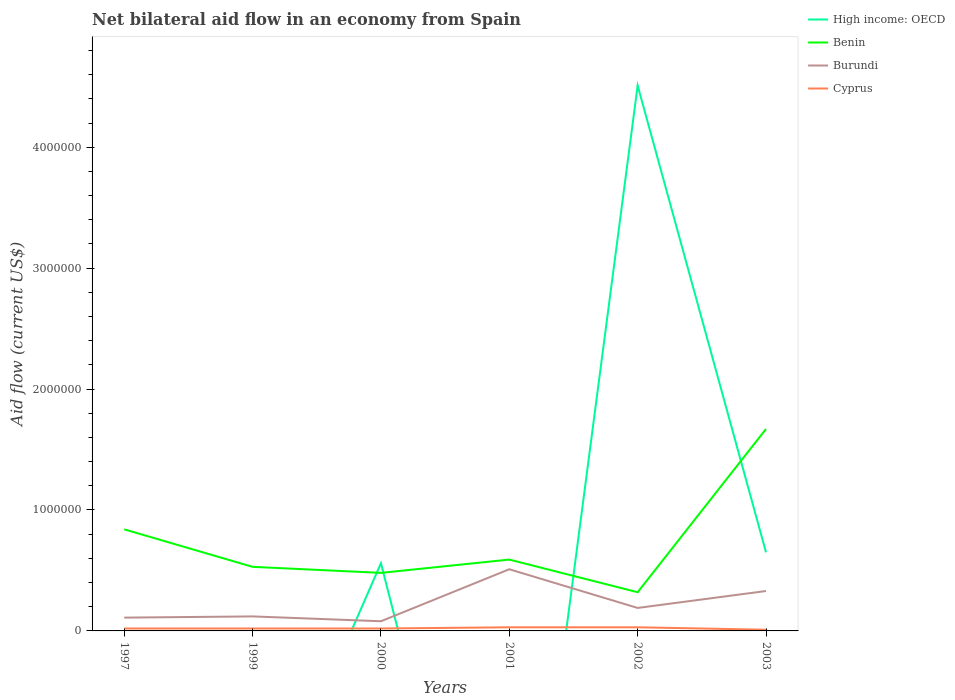Does the line corresponding to Benin intersect with the line corresponding to High income: OECD?
Give a very brief answer. Yes. Across all years, what is the maximum net bilateral aid flow in Benin?
Provide a short and direct response. 3.20e+05. What is the total net bilateral aid flow in Burundi in the graph?
Keep it short and to the point. -3.90e+05. What is the difference between the highest and the second highest net bilateral aid flow in Benin?
Make the answer very short. 1.35e+06. Is the net bilateral aid flow in Cyprus strictly greater than the net bilateral aid flow in Benin over the years?
Ensure brevity in your answer.  Yes. How many years are there in the graph?
Provide a succinct answer. 6. Does the graph contain grids?
Keep it short and to the point. No. Where does the legend appear in the graph?
Your answer should be compact. Top right. How many legend labels are there?
Keep it short and to the point. 4. How are the legend labels stacked?
Offer a terse response. Vertical. What is the title of the graph?
Your answer should be compact. Net bilateral aid flow in an economy from Spain. Does "Heavily indebted poor countries" appear as one of the legend labels in the graph?
Make the answer very short. No. What is the label or title of the X-axis?
Your response must be concise. Years. What is the Aid flow (current US$) of High income: OECD in 1997?
Make the answer very short. 0. What is the Aid flow (current US$) of Benin in 1997?
Offer a terse response. 8.40e+05. What is the Aid flow (current US$) of Burundi in 1997?
Your response must be concise. 1.10e+05. What is the Aid flow (current US$) of High income: OECD in 1999?
Provide a succinct answer. 0. What is the Aid flow (current US$) in Benin in 1999?
Provide a succinct answer. 5.30e+05. What is the Aid flow (current US$) in Burundi in 1999?
Keep it short and to the point. 1.20e+05. What is the Aid flow (current US$) of Cyprus in 1999?
Your answer should be compact. 2.00e+04. What is the Aid flow (current US$) in High income: OECD in 2000?
Offer a terse response. 5.60e+05. What is the Aid flow (current US$) of Benin in 2000?
Give a very brief answer. 4.80e+05. What is the Aid flow (current US$) in Burundi in 2000?
Your answer should be very brief. 8.00e+04. What is the Aid flow (current US$) of High income: OECD in 2001?
Offer a very short reply. 0. What is the Aid flow (current US$) in Benin in 2001?
Make the answer very short. 5.90e+05. What is the Aid flow (current US$) in Burundi in 2001?
Give a very brief answer. 5.10e+05. What is the Aid flow (current US$) of High income: OECD in 2002?
Keep it short and to the point. 4.51e+06. What is the Aid flow (current US$) of Benin in 2002?
Make the answer very short. 3.20e+05. What is the Aid flow (current US$) of Burundi in 2002?
Make the answer very short. 1.90e+05. What is the Aid flow (current US$) of High income: OECD in 2003?
Give a very brief answer. 6.50e+05. What is the Aid flow (current US$) in Benin in 2003?
Offer a terse response. 1.67e+06. What is the Aid flow (current US$) of Burundi in 2003?
Provide a succinct answer. 3.30e+05. Across all years, what is the maximum Aid flow (current US$) of High income: OECD?
Ensure brevity in your answer.  4.51e+06. Across all years, what is the maximum Aid flow (current US$) of Benin?
Offer a terse response. 1.67e+06. Across all years, what is the maximum Aid flow (current US$) in Burundi?
Provide a short and direct response. 5.10e+05. Across all years, what is the maximum Aid flow (current US$) in Cyprus?
Provide a short and direct response. 3.00e+04. Across all years, what is the minimum Aid flow (current US$) of High income: OECD?
Your answer should be compact. 0. Across all years, what is the minimum Aid flow (current US$) in Benin?
Provide a succinct answer. 3.20e+05. Across all years, what is the minimum Aid flow (current US$) of Burundi?
Provide a short and direct response. 8.00e+04. Across all years, what is the minimum Aid flow (current US$) in Cyprus?
Your answer should be compact. 10000. What is the total Aid flow (current US$) in High income: OECD in the graph?
Ensure brevity in your answer.  5.72e+06. What is the total Aid flow (current US$) of Benin in the graph?
Your answer should be very brief. 4.43e+06. What is the total Aid flow (current US$) of Burundi in the graph?
Your answer should be compact. 1.34e+06. What is the difference between the Aid flow (current US$) in Cyprus in 1997 and that in 1999?
Keep it short and to the point. 0. What is the difference between the Aid flow (current US$) of Benin in 1997 and that in 2000?
Provide a short and direct response. 3.60e+05. What is the difference between the Aid flow (current US$) of Burundi in 1997 and that in 2000?
Make the answer very short. 3.00e+04. What is the difference between the Aid flow (current US$) of Cyprus in 1997 and that in 2000?
Make the answer very short. 0. What is the difference between the Aid flow (current US$) in Benin in 1997 and that in 2001?
Give a very brief answer. 2.50e+05. What is the difference between the Aid flow (current US$) in Burundi in 1997 and that in 2001?
Ensure brevity in your answer.  -4.00e+05. What is the difference between the Aid flow (current US$) in Benin in 1997 and that in 2002?
Make the answer very short. 5.20e+05. What is the difference between the Aid flow (current US$) in Burundi in 1997 and that in 2002?
Provide a short and direct response. -8.00e+04. What is the difference between the Aid flow (current US$) in Benin in 1997 and that in 2003?
Keep it short and to the point. -8.30e+05. What is the difference between the Aid flow (current US$) of Cyprus in 1997 and that in 2003?
Your response must be concise. 10000. What is the difference between the Aid flow (current US$) in Burundi in 1999 and that in 2000?
Give a very brief answer. 4.00e+04. What is the difference between the Aid flow (current US$) of Benin in 1999 and that in 2001?
Your answer should be very brief. -6.00e+04. What is the difference between the Aid flow (current US$) of Burundi in 1999 and that in 2001?
Your answer should be compact. -3.90e+05. What is the difference between the Aid flow (current US$) of Cyprus in 1999 and that in 2001?
Provide a succinct answer. -10000. What is the difference between the Aid flow (current US$) of Benin in 1999 and that in 2003?
Make the answer very short. -1.14e+06. What is the difference between the Aid flow (current US$) of Benin in 2000 and that in 2001?
Give a very brief answer. -1.10e+05. What is the difference between the Aid flow (current US$) of Burundi in 2000 and that in 2001?
Make the answer very short. -4.30e+05. What is the difference between the Aid flow (current US$) of Cyprus in 2000 and that in 2001?
Ensure brevity in your answer.  -10000. What is the difference between the Aid flow (current US$) of High income: OECD in 2000 and that in 2002?
Your answer should be compact. -3.95e+06. What is the difference between the Aid flow (current US$) of Burundi in 2000 and that in 2002?
Offer a very short reply. -1.10e+05. What is the difference between the Aid flow (current US$) in Benin in 2000 and that in 2003?
Offer a terse response. -1.19e+06. What is the difference between the Aid flow (current US$) of Burundi in 2000 and that in 2003?
Keep it short and to the point. -2.50e+05. What is the difference between the Aid flow (current US$) in Benin in 2001 and that in 2002?
Your answer should be very brief. 2.70e+05. What is the difference between the Aid flow (current US$) in Cyprus in 2001 and that in 2002?
Offer a very short reply. 0. What is the difference between the Aid flow (current US$) of Benin in 2001 and that in 2003?
Your answer should be compact. -1.08e+06. What is the difference between the Aid flow (current US$) in Burundi in 2001 and that in 2003?
Your response must be concise. 1.80e+05. What is the difference between the Aid flow (current US$) of Cyprus in 2001 and that in 2003?
Provide a short and direct response. 2.00e+04. What is the difference between the Aid flow (current US$) of High income: OECD in 2002 and that in 2003?
Offer a terse response. 3.86e+06. What is the difference between the Aid flow (current US$) in Benin in 2002 and that in 2003?
Make the answer very short. -1.35e+06. What is the difference between the Aid flow (current US$) in Burundi in 2002 and that in 2003?
Your answer should be very brief. -1.40e+05. What is the difference between the Aid flow (current US$) in Cyprus in 2002 and that in 2003?
Your answer should be very brief. 2.00e+04. What is the difference between the Aid flow (current US$) of Benin in 1997 and the Aid flow (current US$) of Burundi in 1999?
Give a very brief answer. 7.20e+05. What is the difference between the Aid flow (current US$) of Benin in 1997 and the Aid flow (current US$) of Cyprus in 1999?
Your answer should be compact. 8.20e+05. What is the difference between the Aid flow (current US$) in Burundi in 1997 and the Aid flow (current US$) in Cyprus in 1999?
Make the answer very short. 9.00e+04. What is the difference between the Aid flow (current US$) of Benin in 1997 and the Aid flow (current US$) of Burundi in 2000?
Ensure brevity in your answer.  7.60e+05. What is the difference between the Aid flow (current US$) in Benin in 1997 and the Aid flow (current US$) in Cyprus in 2000?
Your answer should be very brief. 8.20e+05. What is the difference between the Aid flow (current US$) in Benin in 1997 and the Aid flow (current US$) in Burundi in 2001?
Make the answer very short. 3.30e+05. What is the difference between the Aid flow (current US$) in Benin in 1997 and the Aid flow (current US$) in Cyprus in 2001?
Give a very brief answer. 8.10e+05. What is the difference between the Aid flow (current US$) in Benin in 1997 and the Aid flow (current US$) in Burundi in 2002?
Offer a very short reply. 6.50e+05. What is the difference between the Aid flow (current US$) in Benin in 1997 and the Aid flow (current US$) in Cyprus in 2002?
Keep it short and to the point. 8.10e+05. What is the difference between the Aid flow (current US$) in Benin in 1997 and the Aid flow (current US$) in Burundi in 2003?
Your response must be concise. 5.10e+05. What is the difference between the Aid flow (current US$) of Benin in 1997 and the Aid flow (current US$) of Cyprus in 2003?
Your answer should be very brief. 8.30e+05. What is the difference between the Aid flow (current US$) of Burundi in 1997 and the Aid flow (current US$) of Cyprus in 2003?
Offer a very short reply. 1.00e+05. What is the difference between the Aid flow (current US$) in Benin in 1999 and the Aid flow (current US$) in Cyprus in 2000?
Your response must be concise. 5.10e+05. What is the difference between the Aid flow (current US$) in Burundi in 1999 and the Aid flow (current US$) in Cyprus in 2000?
Your response must be concise. 1.00e+05. What is the difference between the Aid flow (current US$) in Benin in 1999 and the Aid flow (current US$) in Cyprus in 2002?
Offer a terse response. 5.00e+05. What is the difference between the Aid flow (current US$) of Benin in 1999 and the Aid flow (current US$) of Burundi in 2003?
Ensure brevity in your answer.  2.00e+05. What is the difference between the Aid flow (current US$) in Benin in 1999 and the Aid flow (current US$) in Cyprus in 2003?
Offer a terse response. 5.20e+05. What is the difference between the Aid flow (current US$) in Burundi in 1999 and the Aid flow (current US$) in Cyprus in 2003?
Your answer should be compact. 1.10e+05. What is the difference between the Aid flow (current US$) in High income: OECD in 2000 and the Aid flow (current US$) in Benin in 2001?
Your answer should be compact. -3.00e+04. What is the difference between the Aid flow (current US$) in High income: OECD in 2000 and the Aid flow (current US$) in Cyprus in 2001?
Offer a very short reply. 5.30e+05. What is the difference between the Aid flow (current US$) of Benin in 2000 and the Aid flow (current US$) of Burundi in 2001?
Provide a succinct answer. -3.00e+04. What is the difference between the Aid flow (current US$) of Benin in 2000 and the Aid flow (current US$) of Cyprus in 2001?
Offer a terse response. 4.50e+05. What is the difference between the Aid flow (current US$) in High income: OECD in 2000 and the Aid flow (current US$) in Cyprus in 2002?
Your response must be concise. 5.30e+05. What is the difference between the Aid flow (current US$) of High income: OECD in 2000 and the Aid flow (current US$) of Benin in 2003?
Make the answer very short. -1.11e+06. What is the difference between the Aid flow (current US$) of Burundi in 2000 and the Aid flow (current US$) of Cyprus in 2003?
Provide a succinct answer. 7.00e+04. What is the difference between the Aid flow (current US$) in Benin in 2001 and the Aid flow (current US$) in Cyprus in 2002?
Your answer should be very brief. 5.60e+05. What is the difference between the Aid flow (current US$) in Benin in 2001 and the Aid flow (current US$) in Cyprus in 2003?
Your response must be concise. 5.80e+05. What is the difference between the Aid flow (current US$) in High income: OECD in 2002 and the Aid flow (current US$) in Benin in 2003?
Make the answer very short. 2.84e+06. What is the difference between the Aid flow (current US$) in High income: OECD in 2002 and the Aid flow (current US$) in Burundi in 2003?
Provide a short and direct response. 4.18e+06. What is the difference between the Aid flow (current US$) of High income: OECD in 2002 and the Aid flow (current US$) of Cyprus in 2003?
Keep it short and to the point. 4.50e+06. What is the difference between the Aid flow (current US$) in Burundi in 2002 and the Aid flow (current US$) in Cyprus in 2003?
Offer a terse response. 1.80e+05. What is the average Aid flow (current US$) in High income: OECD per year?
Your response must be concise. 9.53e+05. What is the average Aid flow (current US$) of Benin per year?
Your answer should be very brief. 7.38e+05. What is the average Aid flow (current US$) of Burundi per year?
Offer a terse response. 2.23e+05. What is the average Aid flow (current US$) in Cyprus per year?
Your response must be concise. 2.17e+04. In the year 1997, what is the difference between the Aid flow (current US$) of Benin and Aid flow (current US$) of Burundi?
Keep it short and to the point. 7.30e+05. In the year 1997, what is the difference between the Aid flow (current US$) of Benin and Aid flow (current US$) of Cyprus?
Keep it short and to the point. 8.20e+05. In the year 1997, what is the difference between the Aid flow (current US$) in Burundi and Aid flow (current US$) in Cyprus?
Offer a very short reply. 9.00e+04. In the year 1999, what is the difference between the Aid flow (current US$) of Benin and Aid flow (current US$) of Burundi?
Keep it short and to the point. 4.10e+05. In the year 1999, what is the difference between the Aid flow (current US$) in Benin and Aid flow (current US$) in Cyprus?
Offer a terse response. 5.10e+05. In the year 1999, what is the difference between the Aid flow (current US$) in Burundi and Aid flow (current US$) in Cyprus?
Offer a terse response. 1.00e+05. In the year 2000, what is the difference between the Aid flow (current US$) in High income: OECD and Aid flow (current US$) in Burundi?
Offer a terse response. 4.80e+05. In the year 2000, what is the difference between the Aid flow (current US$) in High income: OECD and Aid flow (current US$) in Cyprus?
Provide a short and direct response. 5.40e+05. In the year 2000, what is the difference between the Aid flow (current US$) of Burundi and Aid flow (current US$) of Cyprus?
Give a very brief answer. 6.00e+04. In the year 2001, what is the difference between the Aid flow (current US$) of Benin and Aid flow (current US$) of Burundi?
Provide a short and direct response. 8.00e+04. In the year 2001, what is the difference between the Aid flow (current US$) of Benin and Aid flow (current US$) of Cyprus?
Give a very brief answer. 5.60e+05. In the year 2002, what is the difference between the Aid flow (current US$) of High income: OECD and Aid flow (current US$) of Benin?
Offer a very short reply. 4.19e+06. In the year 2002, what is the difference between the Aid flow (current US$) in High income: OECD and Aid flow (current US$) in Burundi?
Your answer should be compact. 4.32e+06. In the year 2002, what is the difference between the Aid flow (current US$) in High income: OECD and Aid flow (current US$) in Cyprus?
Give a very brief answer. 4.48e+06. In the year 2002, what is the difference between the Aid flow (current US$) in Burundi and Aid flow (current US$) in Cyprus?
Give a very brief answer. 1.60e+05. In the year 2003, what is the difference between the Aid flow (current US$) in High income: OECD and Aid flow (current US$) in Benin?
Make the answer very short. -1.02e+06. In the year 2003, what is the difference between the Aid flow (current US$) of High income: OECD and Aid flow (current US$) of Burundi?
Your answer should be very brief. 3.20e+05. In the year 2003, what is the difference between the Aid flow (current US$) of High income: OECD and Aid flow (current US$) of Cyprus?
Ensure brevity in your answer.  6.40e+05. In the year 2003, what is the difference between the Aid flow (current US$) of Benin and Aid flow (current US$) of Burundi?
Your answer should be very brief. 1.34e+06. In the year 2003, what is the difference between the Aid flow (current US$) in Benin and Aid flow (current US$) in Cyprus?
Give a very brief answer. 1.66e+06. In the year 2003, what is the difference between the Aid flow (current US$) in Burundi and Aid flow (current US$) in Cyprus?
Your response must be concise. 3.20e+05. What is the ratio of the Aid flow (current US$) in Benin in 1997 to that in 1999?
Your answer should be very brief. 1.58. What is the ratio of the Aid flow (current US$) in Burundi in 1997 to that in 1999?
Your answer should be very brief. 0.92. What is the ratio of the Aid flow (current US$) in Benin in 1997 to that in 2000?
Offer a very short reply. 1.75. What is the ratio of the Aid flow (current US$) in Burundi in 1997 to that in 2000?
Offer a terse response. 1.38. What is the ratio of the Aid flow (current US$) of Benin in 1997 to that in 2001?
Give a very brief answer. 1.42. What is the ratio of the Aid flow (current US$) in Burundi in 1997 to that in 2001?
Give a very brief answer. 0.22. What is the ratio of the Aid flow (current US$) of Cyprus in 1997 to that in 2001?
Your answer should be very brief. 0.67. What is the ratio of the Aid flow (current US$) of Benin in 1997 to that in 2002?
Give a very brief answer. 2.62. What is the ratio of the Aid flow (current US$) of Burundi in 1997 to that in 2002?
Offer a terse response. 0.58. What is the ratio of the Aid flow (current US$) in Cyprus in 1997 to that in 2002?
Offer a very short reply. 0.67. What is the ratio of the Aid flow (current US$) of Benin in 1997 to that in 2003?
Make the answer very short. 0.5. What is the ratio of the Aid flow (current US$) of Burundi in 1997 to that in 2003?
Ensure brevity in your answer.  0.33. What is the ratio of the Aid flow (current US$) of Cyprus in 1997 to that in 2003?
Provide a short and direct response. 2. What is the ratio of the Aid flow (current US$) in Benin in 1999 to that in 2000?
Make the answer very short. 1.1. What is the ratio of the Aid flow (current US$) of Burundi in 1999 to that in 2000?
Offer a terse response. 1.5. What is the ratio of the Aid flow (current US$) of Cyprus in 1999 to that in 2000?
Your answer should be compact. 1. What is the ratio of the Aid flow (current US$) in Benin in 1999 to that in 2001?
Your answer should be compact. 0.9. What is the ratio of the Aid flow (current US$) in Burundi in 1999 to that in 2001?
Your answer should be very brief. 0.24. What is the ratio of the Aid flow (current US$) of Cyprus in 1999 to that in 2001?
Ensure brevity in your answer.  0.67. What is the ratio of the Aid flow (current US$) in Benin in 1999 to that in 2002?
Offer a terse response. 1.66. What is the ratio of the Aid flow (current US$) in Burundi in 1999 to that in 2002?
Give a very brief answer. 0.63. What is the ratio of the Aid flow (current US$) in Cyprus in 1999 to that in 2002?
Make the answer very short. 0.67. What is the ratio of the Aid flow (current US$) in Benin in 1999 to that in 2003?
Give a very brief answer. 0.32. What is the ratio of the Aid flow (current US$) in Burundi in 1999 to that in 2003?
Make the answer very short. 0.36. What is the ratio of the Aid flow (current US$) in Benin in 2000 to that in 2001?
Provide a short and direct response. 0.81. What is the ratio of the Aid flow (current US$) in Burundi in 2000 to that in 2001?
Provide a short and direct response. 0.16. What is the ratio of the Aid flow (current US$) in High income: OECD in 2000 to that in 2002?
Provide a succinct answer. 0.12. What is the ratio of the Aid flow (current US$) of Burundi in 2000 to that in 2002?
Give a very brief answer. 0.42. What is the ratio of the Aid flow (current US$) of Cyprus in 2000 to that in 2002?
Ensure brevity in your answer.  0.67. What is the ratio of the Aid flow (current US$) in High income: OECD in 2000 to that in 2003?
Make the answer very short. 0.86. What is the ratio of the Aid flow (current US$) in Benin in 2000 to that in 2003?
Your answer should be very brief. 0.29. What is the ratio of the Aid flow (current US$) of Burundi in 2000 to that in 2003?
Offer a very short reply. 0.24. What is the ratio of the Aid flow (current US$) of Cyprus in 2000 to that in 2003?
Keep it short and to the point. 2. What is the ratio of the Aid flow (current US$) in Benin in 2001 to that in 2002?
Your answer should be very brief. 1.84. What is the ratio of the Aid flow (current US$) in Burundi in 2001 to that in 2002?
Provide a short and direct response. 2.68. What is the ratio of the Aid flow (current US$) of Cyprus in 2001 to that in 2002?
Offer a terse response. 1. What is the ratio of the Aid flow (current US$) in Benin in 2001 to that in 2003?
Offer a terse response. 0.35. What is the ratio of the Aid flow (current US$) of Burundi in 2001 to that in 2003?
Make the answer very short. 1.55. What is the ratio of the Aid flow (current US$) in Cyprus in 2001 to that in 2003?
Make the answer very short. 3. What is the ratio of the Aid flow (current US$) of High income: OECD in 2002 to that in 2003?
Your answer should be compact. 6.94. What is the ratio of the Aid flow (current US$) of Benin in 2002 to that in 2003?
Ensure brevity in your answer.  0.19. What is the ratio of the Aid flow (current US$) of Burundi in 2002 to that in 2003?
Provide a short and direct response. 0.58. What is the difference between the highest and the second highest Aid flow (current US$) of High income: OECD?
Provide a short and direct response. 3.86e+06. What is the difference between the highest and the second highest Aid flow (current US$) in Benin?
Make the answer very short. 8.30e+05. What is the difference between the highest and the second highest Aid flow (current US$) of Burundi?
Offer a very short reply. 1.80e+05. What is the difference between the highest and the second highest Aid flow (current US$) in Cyprus?
Your answer should be compact. 0. What is the difference between the highest and the lowest Aid flow (current US$) in High income: OECD?
Keep it short and to the point. 4.51e+06. What is the difference between the highest and the lowest Aid flow (current US$) in Benin?
Give a very brief answer. 1.35e+06. What is the difference between the highest and the lowest Aid flow (current US$) in Cyprus?
Provide a short and direct response. 2.00e+04. 